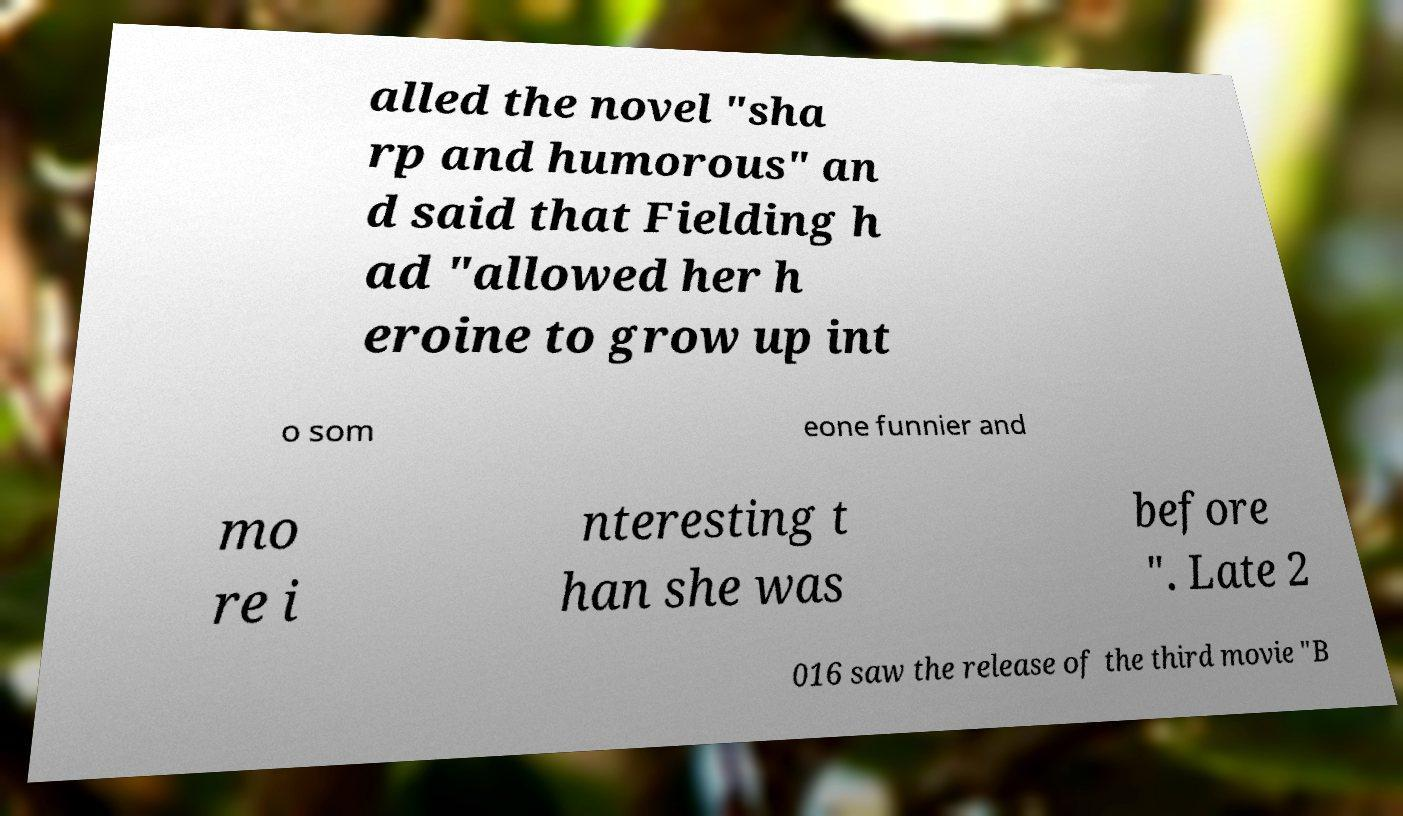For documentation purposes, I need the text within this image transcribed. Could you provide that? alled the novel "sha rp and humorous" an d said that Fielding h ad "allowed her h eroine to grow up int o som eone funnier and mo re i nteresting t han she was before ". Late 2 016 saw the release of the third movie "B 